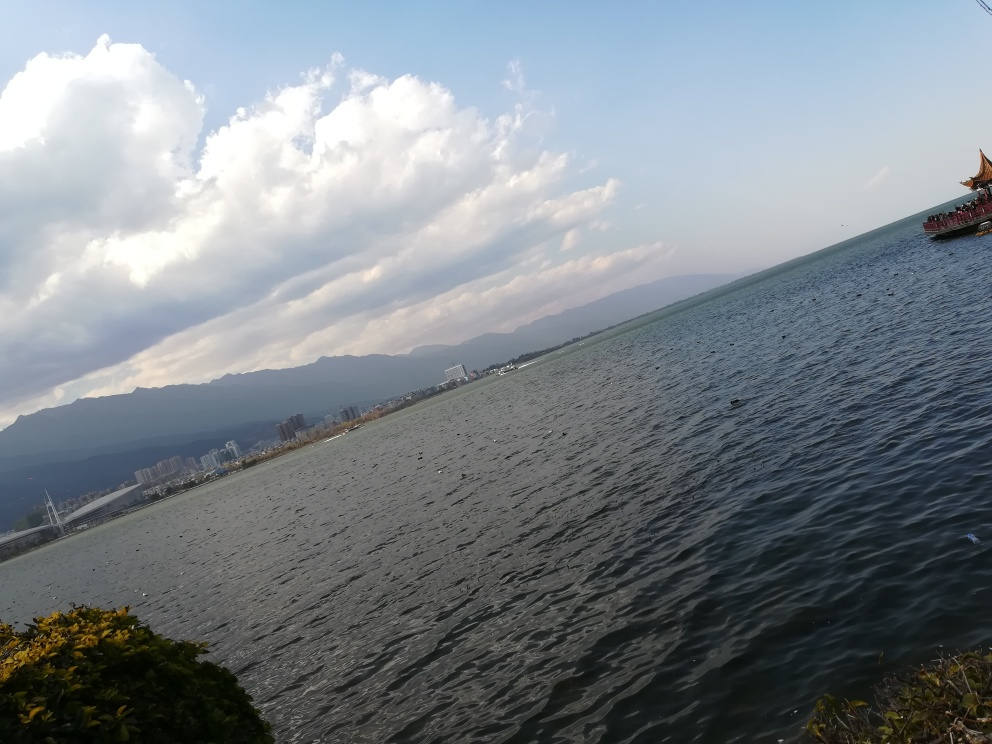Is this place suitable for swimming? There are no visible signs of swimming activity in the image. The suitability for swimming would depend on local conditions such as water quality, safety measures in place, and local regulations. 